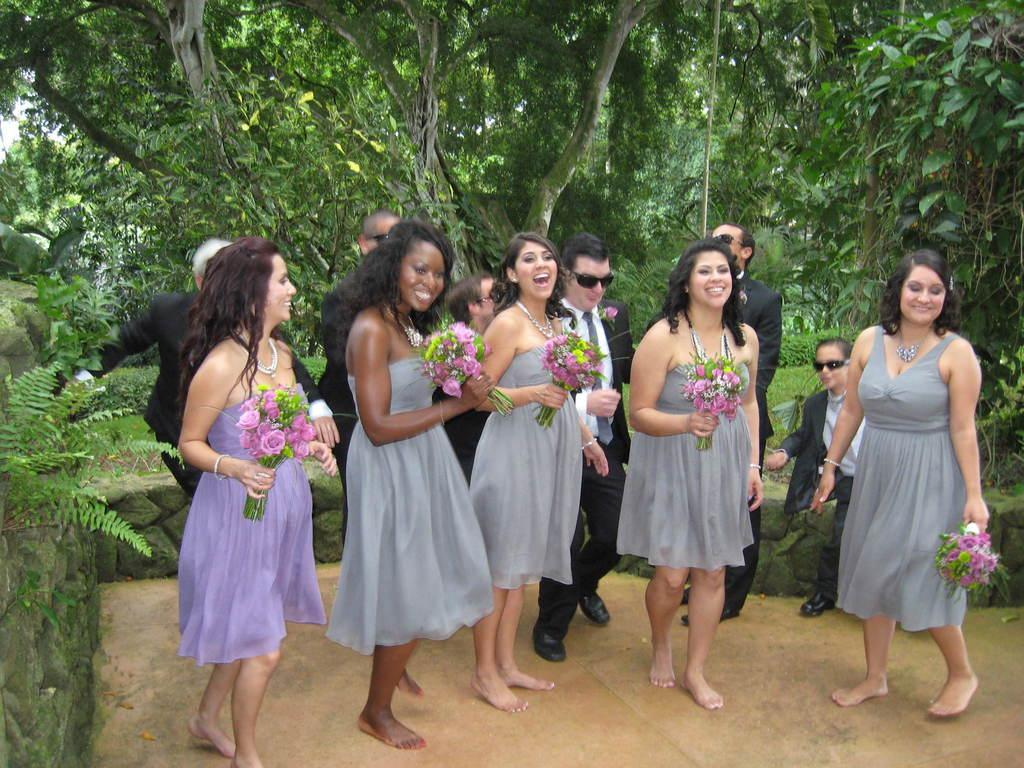Who is present in the image? There are women, a few people, and a kid in the image. What are the women holding in the image? The women are holding flower bouquets in the image. What expressions do the women have in the image? The women are smiling in the image. What type of vegetation can be seen in the image? There are plants, grass, and trees in the image. What type of brake is visible on the tree in the image? There is no brake present in the image, and trees do not have brakes. Who is the owner of the kid in the image? The image does not provide information about the ownership of the kid, and it is not appropriate to assume or speculate about such matters. 